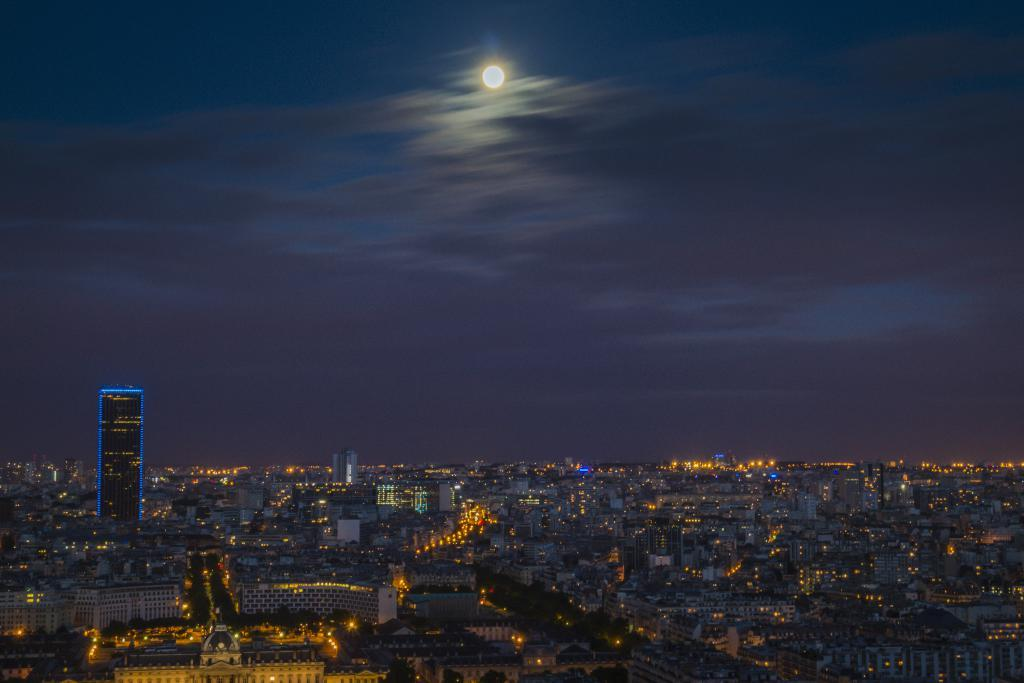What type of structures can be seen in the image? There are buildings in the image. What else is visible in the image besides the buildings? There are lights visible in the image. What can be seen in the background of the image? The sky is visible in the background of the image. What is the condition of the sky in the image? Clouds are present in the sky. What type of skin condition is visible on the minister in the image? There is no minister present in the image, and therefore no skin condition can be observed. 